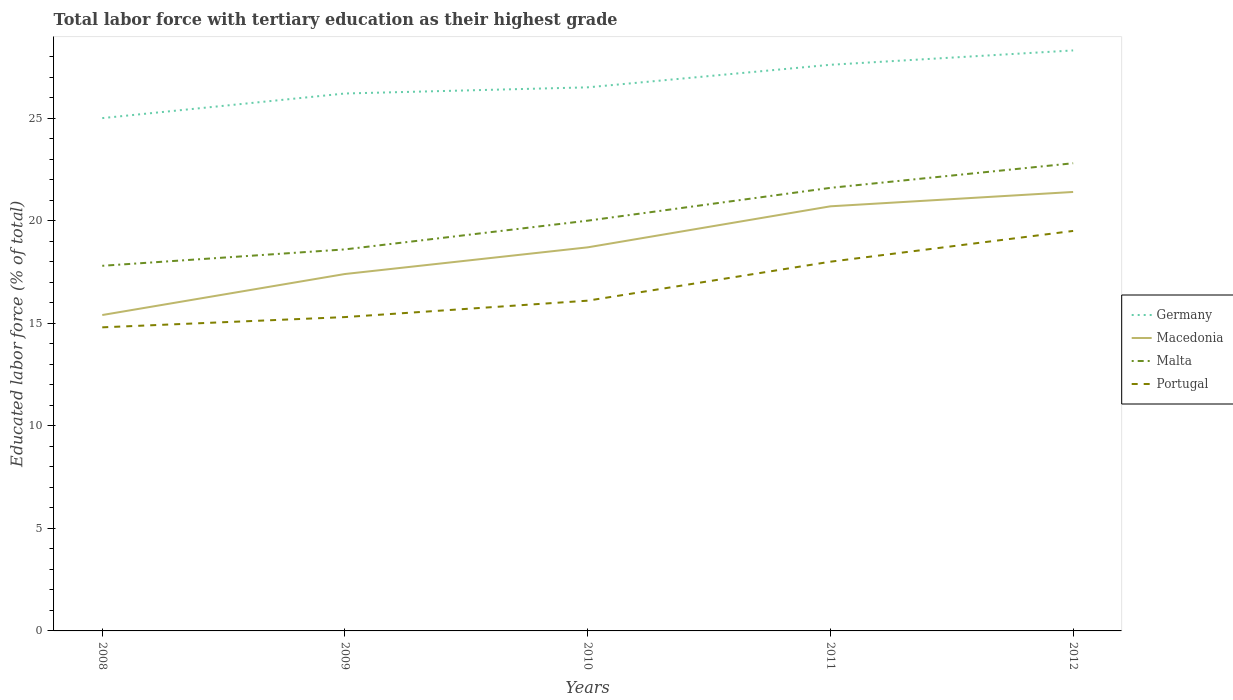How many different coloured lines are there?
Make the answer very short. 4. Is the number of lines equal to the number of legend labels?
Provide a succinct answer. Yes. Across all years, what is the maximum percentage of male labor force with tertiary education in Macedonia?
Your answer should be very brief. 15.4. In which year was the percentage of male labor force with tertiary education in Malta maximum?
Offer a terse response. 2008. What is the total percentage of male labor force with tertiary education in Malta in the graph?
Offer a terse response. -4.2. What is the difference between the highest and the second highest percentage of male labor force with tertiary education in Portugal?
Offer a very short reply. 4.7. What is the difference between the highest and the lowest percentage of male labor force with tertiary education in Portugal?
Keep it short and to the point. 2. Is the percentage of male labor force with tertiary education in Macedonia strictly greater than the percentage of male labor force with tertiary education in Portugal over the years?
Offer a terse response. No. Are the values on the major ticks of Y-axis written in scientific E-notation?
Give a very brief answer. No. Does the graph contain any zero values?
Offer a terse response. No. What is the title of the graph?
Provide a short and direct response. Total labor force with tertiary education as their highest grade. What is the label or title of the X-axis?
Offer a terse response. Years. What is the label or title of the Y-axis?
Offer a very short reply. Educated labor force (% of total). What is the Educated labor force (% of total) in Macedonia in 2008?
Your answer should be very brief. 15.4. What is the Educated labor force (% of total) of Malta in 2008?
Offer a very short reply. 17.8. What is the Educated labor force (% of total) of Portugal in 2008?
Offer a very short reply. 14.8. What is the Educated labor force (% of total) in Germany in 2009?
Make the answer very short. 26.2. What is the Educated labor force (% of total) in Macedonia in 2009?
Keep it short and to the point. 17.4. What is the Educated labor force (% of total) of Malta in 2009?
Your answer should be very brief. 18.6. What is the Educated labor force (% of total) of Portugal in 2009?
Keep it short and to the point. 15.3. What is the Educated labor force (% of total) in Macedonia in 2010?
Provide a succinct answer. 18.7. What is the Educated labor force (% of total) in Malta in 2010?
Your answer should be very brief. 20. What is the Educated labor force (% of total) of Portugal in 2010?
Offer a very short reply. 16.1. What is the Educated labor force (% of total) of Germany in 2011?
Provide a succinct answer. 27.6. What is the Educated labor force (% of total) in Macedonia in 2011?
Offer a terse response. 20.7. What is the Educated labor force (% of total) of Malta in 2011?
Ensure brevity in your answer.  21.6. What is the Educated labor force (% of total) of Germany in 2012?
Provide a succinct answer. 28.3. What is the Educated labor force (% of total) of Macedonia in 2012?
Provide a short and direct response. 21.4. What is the Educated labor force (% of total) in Malta in 2012?
Ensure brevity in your answer.  22.8. Across all years, what is the maximum Educated labor force (% of total) in Germany?
Make the answer very short. 28.3. Across all years, what is the maximum Educated labor force (% of total) of Macedonia?
Provide a succinct answer. 21.4. Across all years, what is the maximum Educated labor force (% of total) of Malta?
Your answer should be very brief. 22.8. Across all years, what is the maximum Educated labor force (% of total) of Portugal?
Make the answer very short. 19.5. Across all years, what is the minimum Educated labor force (% of total) in Germany?
Give a very brief answer. 25. Across all years, what is the minimum Educated labor force (% of total) in Macedonia?
Give a very brief answer. 15.4. Across all years, what is the minimum Educated labor force (% of total) of Malta?
Make the answer very short. 17.8. Across all years, what is the minimum Educated labor force (% of total) of Portugal?
Keep it short and to the point. 14.8. What is the total Educated labor force (% of total) in Germany in the graph?
Offer a very short reply. 133.6. What is the total Educated labor force (% of total) in Macedonia in the graph?
Give a very brief answer. 93.6. What is the total Educated labor force (% of total) of Malta in the graph?
Offer a very short reply. 100.8. What is the total Educated labor force (% of total) in Portugal in the graph?
Your answer should be very brief. 83.7. What is the difference between the Educated labor force (% of total) of Germany in 2008 and that in 2009?
Your answer should be very brief. -1.2. What is the difference between the Educated labor force (% of total) of Germany in 2008 and that in 2010?
Offer a very short reply. -1.5. What is the difference between the Educated labor force (% of total) of Malta in 2008 and that in 2010?
Provide a short and direct response. -2.2. What is the difference between the Educated labor force (% of total) of Portugal in 2008 and that in 2010?
Provide a short and direct response. -1.3. What is the difference between the Educated labor force (% of total) of Germany in 2008 and that in 2011?
Provide a short and direct response. -2.6. What is the difference between the Educated labor force (% of total) in Portugal in 2008 and that in 2011?
Offer a terse response. -3.2. What is the difference between the Educated labor force (% of total) of Germany in 2008 and that in 2012?
Your response must be concise. -3.3. What is the difference between the Educated labor force (% of total) of Germany in 2009 and that in 2010?
Your response must be concise. -0.3. What is the difference between the Educated labor force (% of total) in Macedonia in 2009 and that in 2010?
Ensure brevity in your answer.  -1.3. What is the difference between the Educated labor force (% of total) in Malta in 2009 and that in 2010?
Give a very brief answer. -1.4. What is the difference between the Educated labor force (% of total) of Macedonia in 2009 and that in 2011?
Offer a terse response. -3.3. What is the difference between the Educated labor force (% of total) of Malta in 2009 and that in 2011?
Offer a terse response. -3. What is the difference between the Educated labor force (% of total) in Portugal in 2009 and that in 2011?
Offer a very short reply. -2.7. What is the difference between the Educated labor force (% of total) of Germany in 2009 and that in 2012?
Give a very brief answer. -2.1. What is the difference between the Educated labor force (% of total) in Malta in 2009 and that in 2012?
Your answer should be compact. -4.2. What is the difference between the Educated labor force (% of total) of Portugal in 2009 and that in 2012?
Offer a very short reply. -4.2. What is the difference between the Educated labor force (% of total) in Macedonia in 2010 and that in 2011?
Your answer should be very brief. -2. What is the difference between the Educated labor force (% of total) in Germany in 2010 and that in 2012?
Provide a short and direct response. -1.8. What is the difference between the Educated labor force (% of total) in Macedonia in 2010 and that in 2012?
Give a very brief answer. -2.7. What is the difference between the Educated labor force (% of total) of Macedonia in 2011 and that in 2012?
Offer a terse response. -0.7. What is the difference between the Educated labor force (% of total) of Portugal in 2011 and that in 2012?
Keep it short and to the point. -1.5. What is the difference between the Educated labor force (% of total) of Germany in 2008 and the Educated labor force (% of total) of Macedonia in 2009?
Offer a very short reply. 7.6. What is the difference between the Educated labor force (% of total) in Germany in 2008 and the Educated labor force (% of total) in Portugal in 2009?
Make the answer very short. 9.7. What is the difference between the Educated labor force (% of total) in Macedonia in 2008 and the Educated labor force (% of total) in Malta in 2009?
Provide a short and direct response. -3.2. What is the difference between the Educated labor force (% of total) in Germany in 2008 and the Educated labor force (% of total) in Macedonia in 2010?
Your answer should be very brief. 6.3. What is the difference between the Educated labor force (% of total) of Germany in 2008 and the Educated labor force (% of total) of Malta in 2010?
Ensure brevity in your answer.  5. What is the difference between the Educated labor force (% of total) in Macedonia in 2008 and the Educated labor force (% of total) in Malta in 2010?
Provide a succinct answer. -4.6. What is the difference between the Educated labor force (% of total) of Macedonia in 2008 and the Educated labor force (% of total) of Portugal in 2010?
Offer a very short reply. -0.7. What is the difference between the Educated labor force (% of total) of Germany in 2008 and the Educated labor force (% of total) of Malta in 2011?
Keep it short and to the point. 3.4. What is the difference between the Educated labor force (% of total) in Germany in 2008 and the Educated labor force (% of total) in Portugal in 2011?
Ensure brevity in your answer.  7. What is the difference between the Educated labor force (% of total) in Germany in 2008 and the Educated labor force (% of total) in Malta in 2012?
Provide a short and direct response. 2.2. What is the difference between the Educated labor force (% of total) of Germany in 2008 and the Educated labor force (% of total) of Portugal in 2012?
Provide a succinct answer. 5.5. What is the difference between the Educated labor force (% of total) of Macedonia in 2008 and the Educated labor force (% of total) of Malta in 2012?
Keep it short and to the point. -7.4. What is the difference between the Educated labor force (% of total) in Germany in 2009 and the Educated labor force (% of total) in Macedonia in 2010?
Keep it short and to the point. 7.5. What is the difference between the Educated labor force (% of total) in Macedonia in 2009 and the Educated labor force (% of total) in Malta in 2010?
Keep it short and to the point. -2.6. What is the difference between the Educated labor force (% of total) in Germany in 2009 and the Educated labor force (% of total) in Portugal in 2011?
Your answer should be compact. 8.2. What is the difference between the Educated labor force (% of total) in Germany in 2009 and the Educated labor force (% of total) in Malta in 2012?
Provide a short and direct response. 3.4. What is the difference between the Educated labor force (% of total) of Germany in 2009 and the Educated labor force (% of total) of Portugal in 2012?
Your response must be concise. 6.7. What is the difference between the Educated labor force (% of total) in Macedonia in 2009 and the Educated labor force (% of total) in Portugal in 2012?
Offer a terse response. -2.1. What is the difference between the Educated labor force (% of total) in Malta in 2009 and the Educated labor force (% of total) in Portugal in 2012?
Provide a short and direct response. -0.9. What is the difference between the Educated labor force (% of total) of Germany in 2010 and the Educated labor force (% of total) of Malta in 2011?
Your answer should be very brief. 4.9. What is the difference between the Educated labor force (% of total) in Germany in 2010 and the Educated labor force (% of total) in Macedonia in 2012?
Your response must be concise. 5.1. What is the difference between the Educated labor force (% of total) in Germany in 2010 and the Educated labor force (% of total) in Malta in 2012?
Provide a succinct answer. 3.7. What is the difference between the Educated labor force (% of total) in Germany in 2010 and the Educated labor force (% of total) in Portugal in 2012?
Provide a succinct answer. 7. What is the difference between the Educated labor force (% of total) of Macedonia in 2010 and the Educated labor force (% of total) of Malta in 2012?
Offer a terse response. -4.1. What is the difference between the Educated labor force (% of total) of Malta in 2010 and the Educated labor force (% of total) of Portugal in 2012?
Give a very brief answer. 0.5. What is the difference between the Educated labor force (% of total) in Germany in 2011 and the Educated labor force (% of total) in Portugal in 2012?
Your answer should be very brief. 8.1. What is the difference between the Educated labor force (% of total) in Macedonia in 2011 and the Educated labor force (% of total) in Malta in 2012?
Your answer should be very brief. -2.1. What is the average Educated labor force (% of total) in Germany per year?
Ensure brevity in your answer.  26.72. What is the average Educated labor force (% of total) in Macedonia per year?
Provide a short and direct response. 18.72. What is the average Educated labor force (% of total) of Malta per year?
Make the answer very short. 20.16. What is the average Educated labor force (% of total) in Portugal per year?
Offer a very short reply. 16.74. In the year 2008, what is the difference between the Educated labor force (% of total) in Macedonia and Educated labor force (% of total) in Portugal?
Your answer should be compact. 0.6. In the year 2008, what is the difference between the Educated labor force (% of total) in Malta and Educated labor force (% of total) in Portugal?
Provide a succinct answer. 3. In the year 2009, what is the difference between the Educated labor force (% of total) in Germany and Educated labor force (% of total) in Malta?
Ensure brevity in your answer.  7.6. In the year 2009, what is the difference between the Educated labor force (% of total) of Germany and Educated labor force (% of total) of Portugal?
Offer a very short reply. 10.9. In the year 2009, what is the difference between the Educated labor force (% of total) in Macedonia and Educated labor force (% of total) in Malta?
Offer a very short reply. -1.2. In the year 2009, what is the difference between the Educated labor force (% of total) in Macedonia and Educated labor force (% of total) in Portugal?
Your response must be concise. 2.1. In the year 2010, what is the difference between the Educated labor force (% of total) in Germany and Educated labor force (% of total) in Portugal?
Offer a terse response. 10.4. In the year 2010, what is the difference between the Educated labor force (% of total) in Macedonia and Educated labor force (% of total) in Malta?
Offer a very short reply. -1.3. In the year 2010, what is the difference between the Educated labor force (% of total) of Malta and Educated labor force (% of total) of Portugal?
Provide a short and direct response. 3.9. In the year 2011, what is the difference between the Educated labor force (% of total) in Germany and Educated labor force (% of total) in Macedonia?
Offer a very short reply. 6.9. In the year 2011, what is the difference between the Educated labor force (% of total) of Macedonia and Educated labor force (% of total) of Malta?
Ensure brevity in your answer.  -0.9. In the year 2011, what is the difference between the Educated labor force (% of total) in Macedonia and Educated labor force (% of total) in Portugal?
Keep it short and to the point. 2.7. In the year 2012, what is the difference between the Educated labor force (% of total) in Germany and Educated labor force (% of total) in Portugal?
Provide a succinct answer. 8.8. In the year 2012, what is the difference between the Educated labor force (% of total) in Macedonia and Educated labor force (% of total) in Malta?
Provide a short and direct response. -1.4. In the year 2012, what is the difference between the Educated labor force (% of total) of Malta and Educated labor force (% of total) of Portugal?
Provide a succinct answer. 3.3. What is the ratio of the Educated labor force (% of total) in Germany in 2008 to that in 2009?
Give a very brief answer. 0.95. What is the ratio of the Educated labor force (% of total) in Macedonia in 2008 to that in 2009?
Keep it short and to the point. 0.89. What is the ratio of the Educated labor force (% of total) of Portugal in 2008 to that in 2009?
Provide a succinct answer. 0.97. What is the ratio of the Educated labor force (% of total) of Germany in 2008 to that in 2010?
Provide a succinct answer. 0.94. What is the ratio of the Educated labor force (% of total) of Macedonia in 2008 to that in 2010?
Offer a terse response. 0.82. What is the ratio of the Educated labor force (% of total) of Malta in 2008 to that in 2010?
Give a very brief answer. 0.89. What is the ratio of the Educated labor force (% of total) of Portugal in 2008 to that in 2010?
Offer a terse response. 0.92. What is the ratio of the Educated labor force (% of total) in Germany in 2008 to that in 2011?
Offer a very short reply. 0.91. What is the ratio of the Educated labor force (% of total) in Macedonia in 2008 to that in 2011?
Keep it short and to the point. 0.74. What is the ratio of the Educated labor force (% of total) of Malta in 2008 to that in 2011?
Provide a short and direct response. 0.82. What is the ratio of the Educated labor force (% of total) in Portugal in 2008 to that in 2011?
Provide a short and direct response. 0.82. What is the ratio of the Educated labor force (% of total) in Germany in 2008 to that in 2012?
Make the answer very short. 0.88. What is the ratio of the Educated labor force (% of total) of Macedonia in 2008 to that in 2012?
Your answer should be compact. 0.72. What is the ratio of the Educated labor force (% of total) in Malta in 2008 to that in 2012?
Your answer should be very brief. 0.78. What is the ratio of the Educated labor force (% of total) in Portugal in 2008 to that in 2012?
Your answer should be very brief. 0.76. What is the ratio of the Educated labor force (% of total) in Germany in 2009 to that in 2010?
Your answer should be very brief. 0.99. What is the ratio of the Educated labor force (% of total) of Macedonia in 2009 to that in 2010?
Make the answer very short. 0.93. What is the ratio of the Educated labor force (% of total) of Malta in 2009 to that in 2010?
Your answer should be compact. 0.93. What is the ratio of the Educated labor force (% of total) in Portugal in 2009 to that in 2010?
Make the answer very short. 0.95. What is the ratio of the Educated labor force (% of total) of Germany in 2009 to that in 2011?
Your response must be concise. 0.95. What is the ratio of the Educated labor force (% of total) in Macedonia in 2009 to that in 2011?
Your answer should be compact. 0.84. What is the ratio of the Educated labor force (% of total) of Malta in 2009 to that in 2011?
Offer a terse response. 0.86. What is the ratio of the Educated labor force (% of total) of Portugal in 2009 to that in 2011?
Give a very brief answer. 0.85. What is the ratio of the Educated labor force (% of total) in Germany in 2009 to that in 2012?
Give a very brief answer. 0.93. What is the ratio of the Educated labor force (% of total) in Macedonia in 2009 to that in 2012?
Provide a short and direct response. 0.81. What is the ratio of the Educated labor force (% of total) in Malta in 2009 to that in 2012?
Your answer should be very brief. 0.82. What is the ratio of the Educated labor force (% of total) in Portugal in 2009 to that in 2012?
Provide a short and direct response. 0.78. What is the ratio of the Educated labor force (% of total) of Germany in 2010 to that in 2011?
Offer a very short reply. 0.96. What is the ratio of the Educated labor force (% of total) of Macedonia in 2010 to that in 2011?
Your answer should be compact. 0.9. What is the ratio of the Educated labor force (% of total) in Malta in 2010 to that in 2011?
Make the answer very short. 0.93. What is the ratio of the Educated labor force (% of total) in Portugal in 2010 to that in 2011?
Make the answer very short. 0.89. What is the ratio of the Educated labor force (% of total) of Germany in 2010 to that in 2012?
Provide a short and direct response. 0.94. What is the ratio of the Educated labor force (% of total) of Macedonia in 2010 to that in 2012?
Provide a succinct answer. 0.87. What is the ratio of the Educated labor force (% of total) of Malta in 2010 to that in 2012?
Provide a succinct answer. 0.88. What is the ratio of the Educated labor force (% of total) of Portugal in 2010 to that in 2012?
Offer a very short reply. 0.83. What is the ratio of the Educated labor force (% of total) of Germany in 2011 to that in 2012?
Make the answer very short. 0.98. What is the ratio of the Educated labor force (% of total) in Macedonia in 2011 to that in 2012?
Make the answer very short. 0.97. What is the ratio of the Educated labor force (% of total) of Malta in 2011 to that in 2012?
Provide a short and direct response. 0.95. What is the ratio of the Educated labor force (% of total) in Portugal in 2011 to that in 2012?
Your response must be concise. 0.92. What is the difference between the highest and the second highest Educated labor force (% of total) in Germany?
Provide a short and direct response. 0.7. What is the difference between the highest and the second highest Educated labor force (% of total) in Malta?
Your answer should be very brief. 1.2. What is the difference between the highest and the lowest Educated labor force (% of total) of Malta?
Ensure brevity in your answer.  5. 